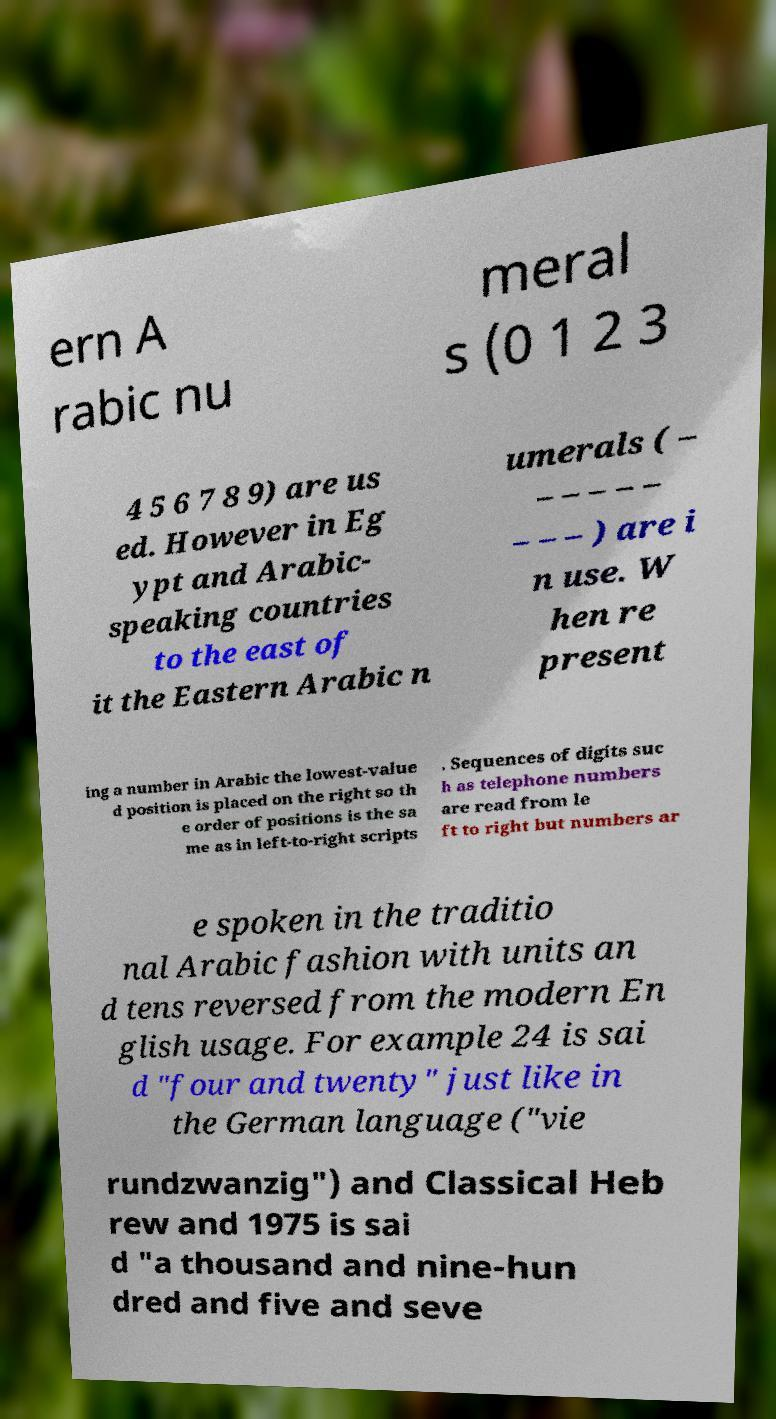Could you assist in decoding the text presented in this image and type it out clearly? ern A rabic nu meral s (0 1 2 3 4 5 6 7 8 9) are us ed. However in Eg ypt and Arabic- speaking countries to the east of it the Eastern Arabic n umerals ( – – – – – – – – – ) are i n use. W hen re present ing a number in Arabic the lowest-value d position is placed on the right so th e order of positions is the sa me as in left-to-right scripts . Sequences of digits suc h as telephone numbers are read from le ft to right but numbers ar e spoken in the traditio nal Arabic fashion with units an d tens reversed from the modern En glish usage. For example 24 is sai d "four and twenty" just like in the German language ("vie rundzwanzig") and Classical Heb rew and 1975 is sai d "a thousand and nine-hun dred and five and seve 